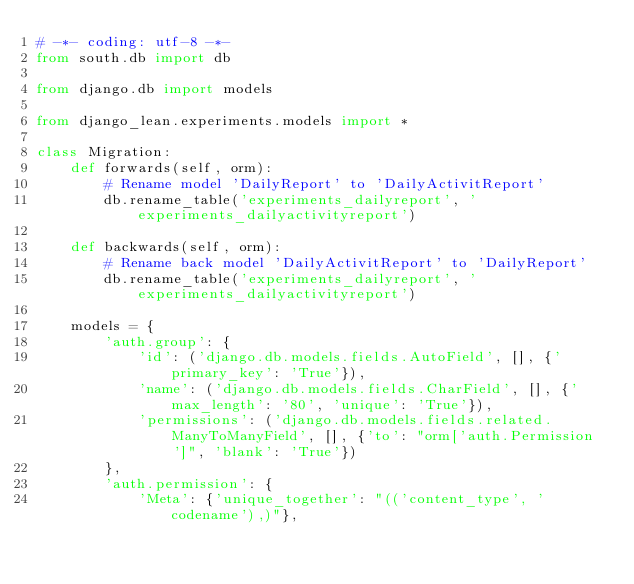Convert code to text. <code><loc_0><loc_0><loc_500><loc_500><_Python_># -*- coding: utf-8 -*-
from south.db import db

from django.db import models

from django_lean.experiments.models import *

class Migration:
    def forwards(self, orm):
        # Rename model 'DailyReport' to 'DailyActivitReport'
        db.rename_table('experiments_dailyreport', 'experiments_dailyactivityreport')
    
    def backwards(self, orm):    
        # Rename back model 'DailyActivitReport' to 'DailyReport'
        db.rename_table('experiments_dailyreport', 'experiments_dailyactivityreport')        
    
    models = {
        'auth.group': {
            'id': ('django.db.models.fields.AutoField', [], {'primary_key': 'True'}),
            'name': ('django.db.models.fields.CharField', [], {'max_length': '80', 'unique': 'True'}),
            'permissions': ('django.db.models.fields.related.ManyToManyField', [], {'to': "orm['auth.Permission']", 'blank': 'True'})
        },
        'auth.permission': {
            'Meta': {'unique_together': "(('content_type', 'codename'),)"},</code> 